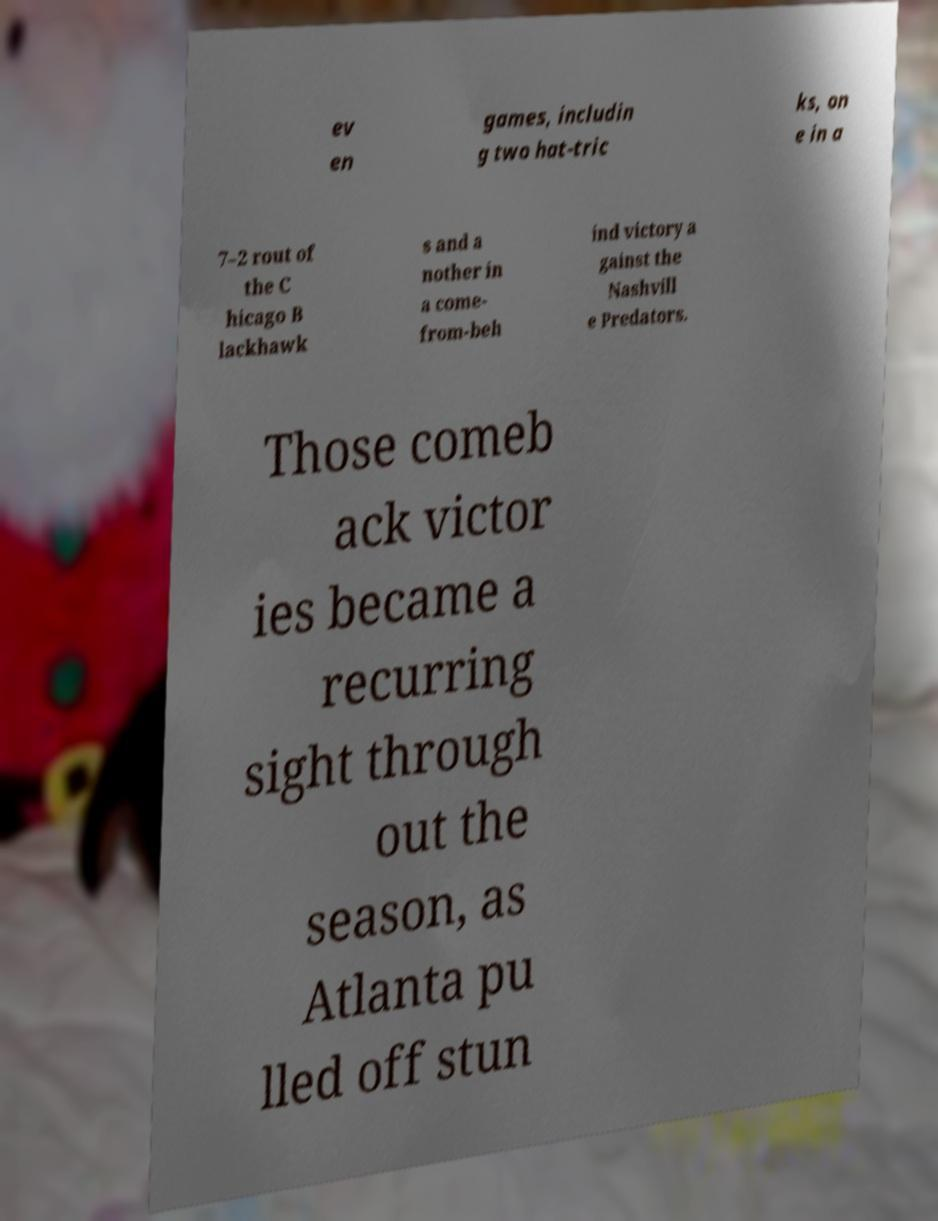For documentation purposes, I need the text within this image transcribed. Could you provide that? ev en games, includin g two hat-tric ks, on e in a 7–2 rout of the C hicago B lackhawk s and a nother in a come- from-beh ind victory a gainst the Nashvill e Predators. Those comeb ack victor ies became a recurring sight through out the season, as Atlanta pu lled off stun 